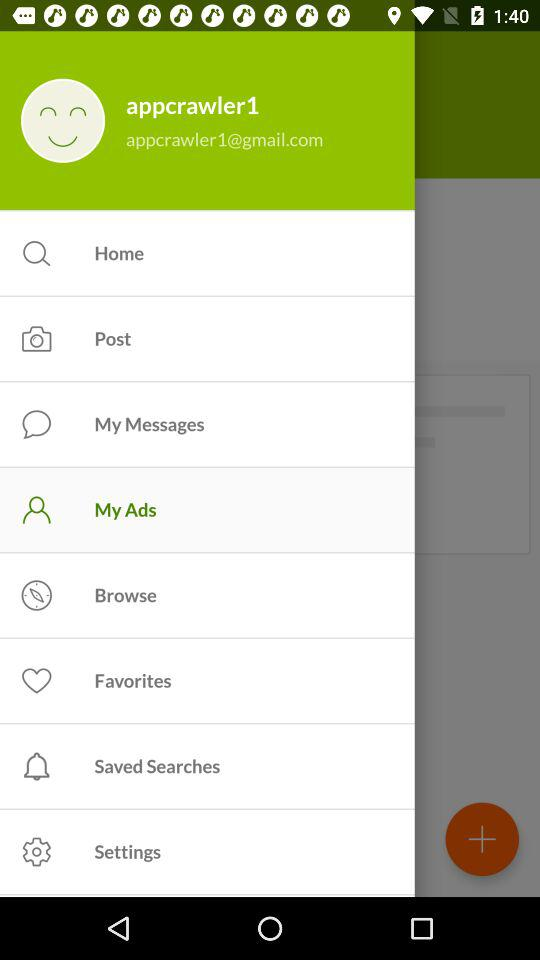What is the selected item in the menu? The selected item in the menu is "My ads". 